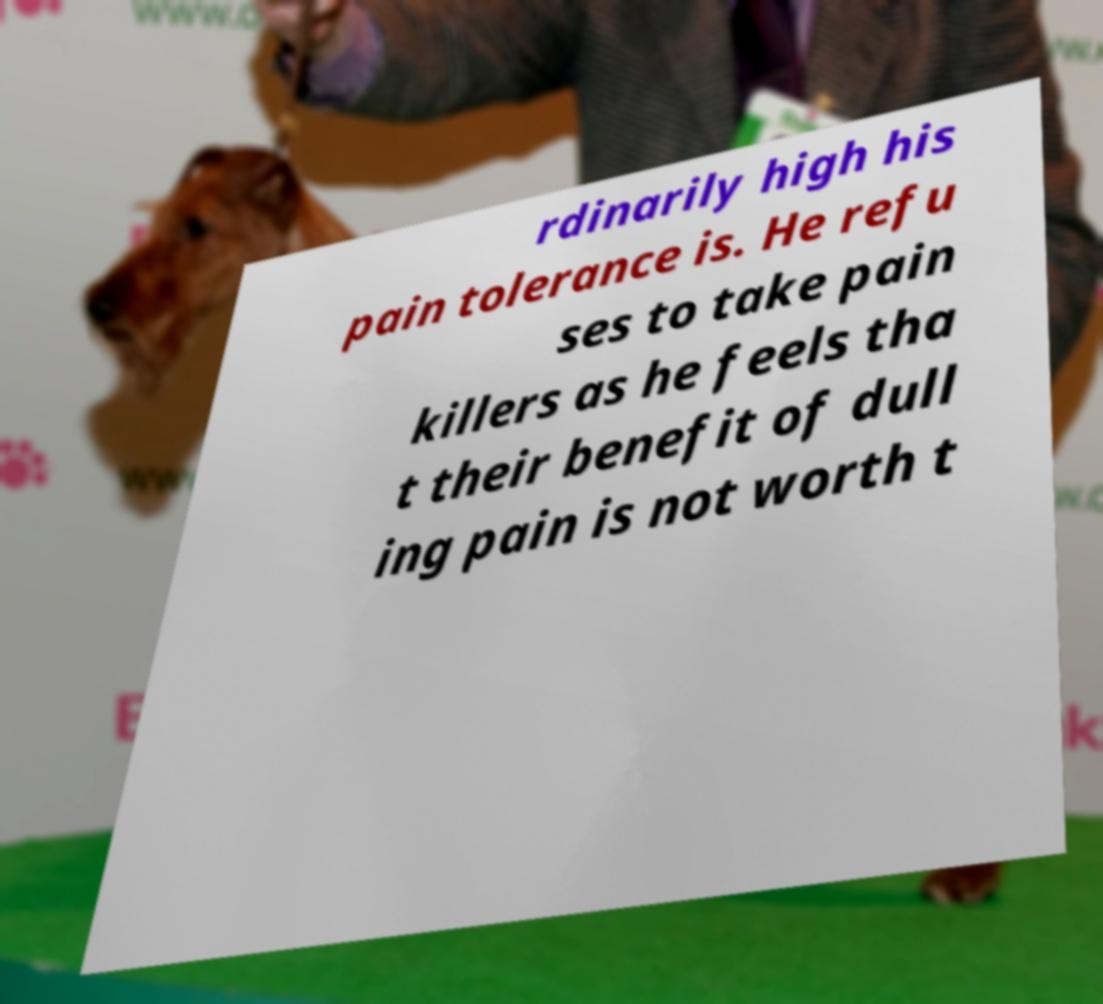Could you assist in decoding the text presented in this image and type it out clearly? rdinarily high his pain tolerance is. He refu ses to take pain killers as he feels tha t their benefit of dull ing pain is not worth t 